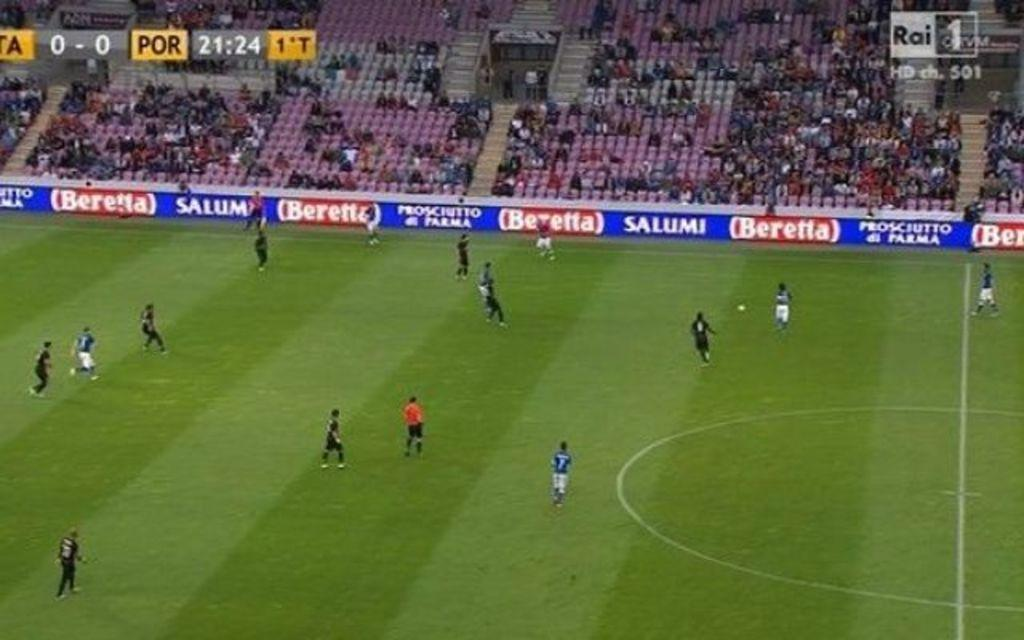<image>
Provide a brief description of the given image. 21:24 is the game time shown on the clock of this soccer match. 